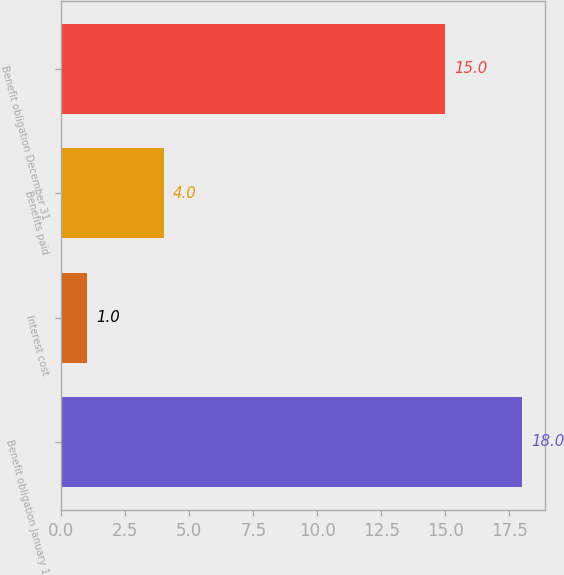Convert chart. <chart><loc_0><loc_0><loc_500><loc_500><bar_chart><fcel>Benefit obligation January 1<fcel>Interest cost<fcel>Benefits paid<fcel>Benefit obligation December 31<nl><fcel>18<fcel>1<fcel>4<fcel>15<nl></chart> 